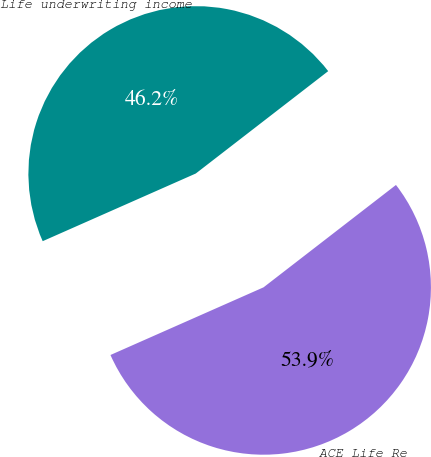Convert chart. <chart><loc_0><loc_0><loc_500><loc_500><pie_chart><fcel>ACE Life Re<fcel>Life underwriting income<nl><fcel>53.85%<fcel>46.15%<nl></chart> 